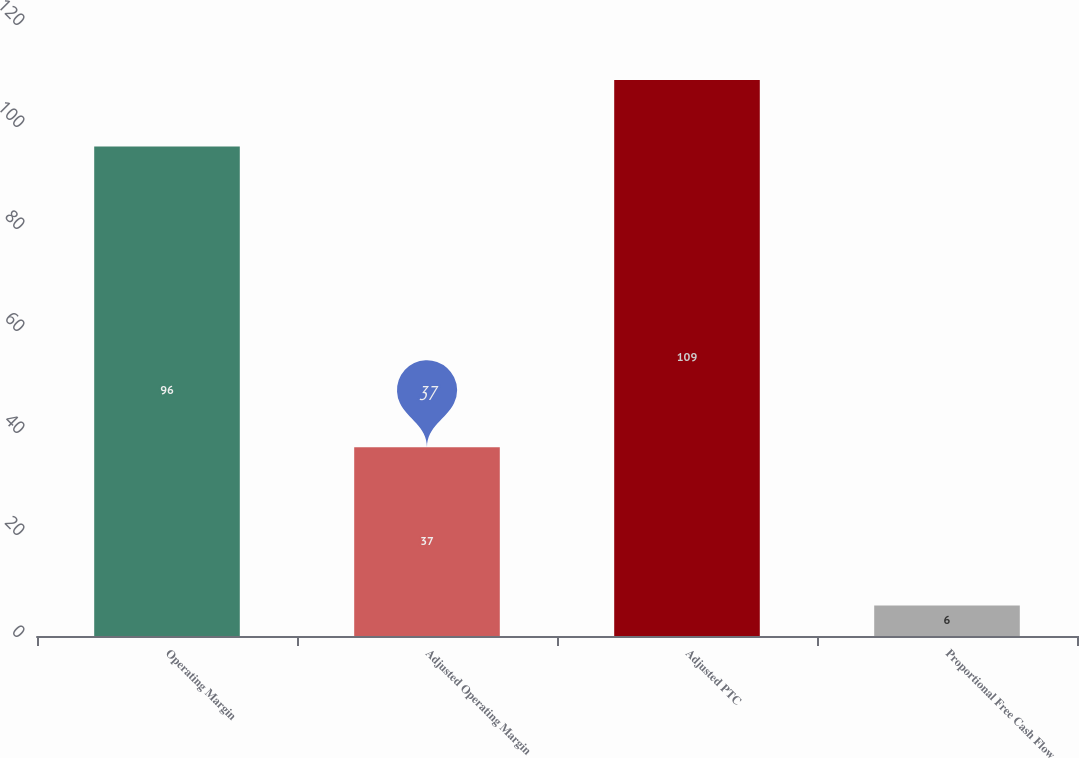Convert chart to OTSL. <chart><loc_0><loc_0><loc_500><loc_500><bar_chart><fcel>Operating Margin<fcel>Adjusted Operating Margin<fcel>Adjusted PTC<fcel>Proportional Free Cash Flow<nl><fcel>96<fcel>37<fcel>109<fcel>6<nl></chart> 